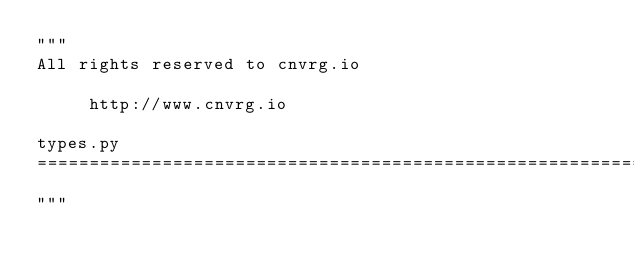<code> <loc_0><loc_0><loc_500><loc_500><_Python_>"""
All rights reserved to cnvrg.io

     http://www.cnvrg.io

types.py
==============================================================================
"""

</code> 